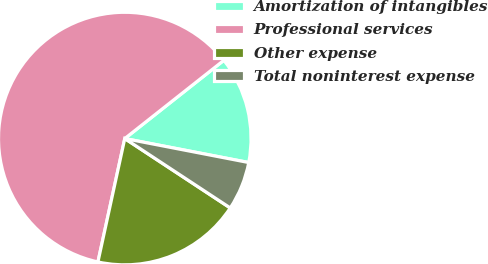Convert chart. <chart><loc_0><loc_0><loc_500><loc_500><pie_chart><fcel>Amortization of intangibles<fcel>Professional services<fcel>Other expense<fcel>Total noninterest expense<nl><fcel>13.68%<fcel>60.95%<fcel>19.15%<fcel>6.22%<nl></chart> 